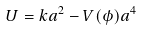<formula> <loc_0><loc_0><loc_500><loc_500>U = k a ^ { 2 } - V ( \phi ) a ^ { 4 }</formula> 